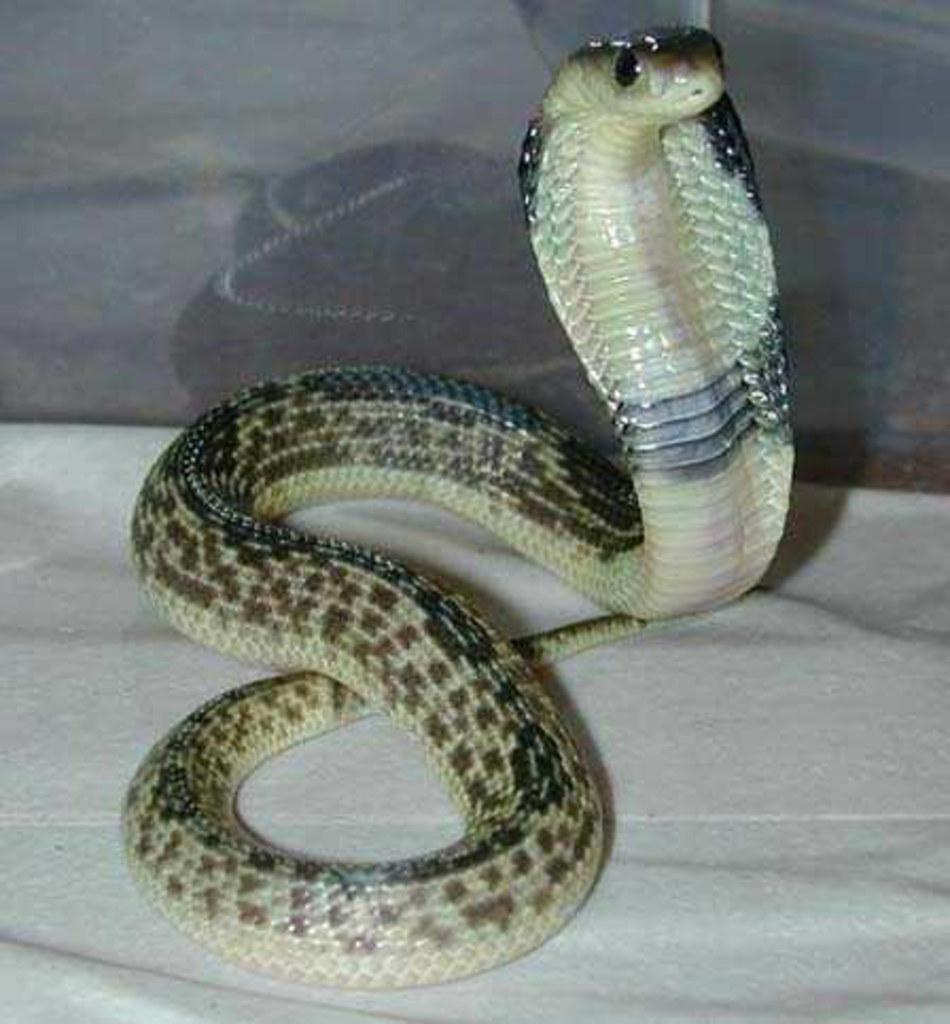What type of animal is in the image? There is a snake in the image. What is located at the bottom of the image? There is a cloth at the bottom of the image. What type of berry is being used to teach the snake in the image? There is no berry present in the image, nor is there any indication that the snake is being taught anything. 